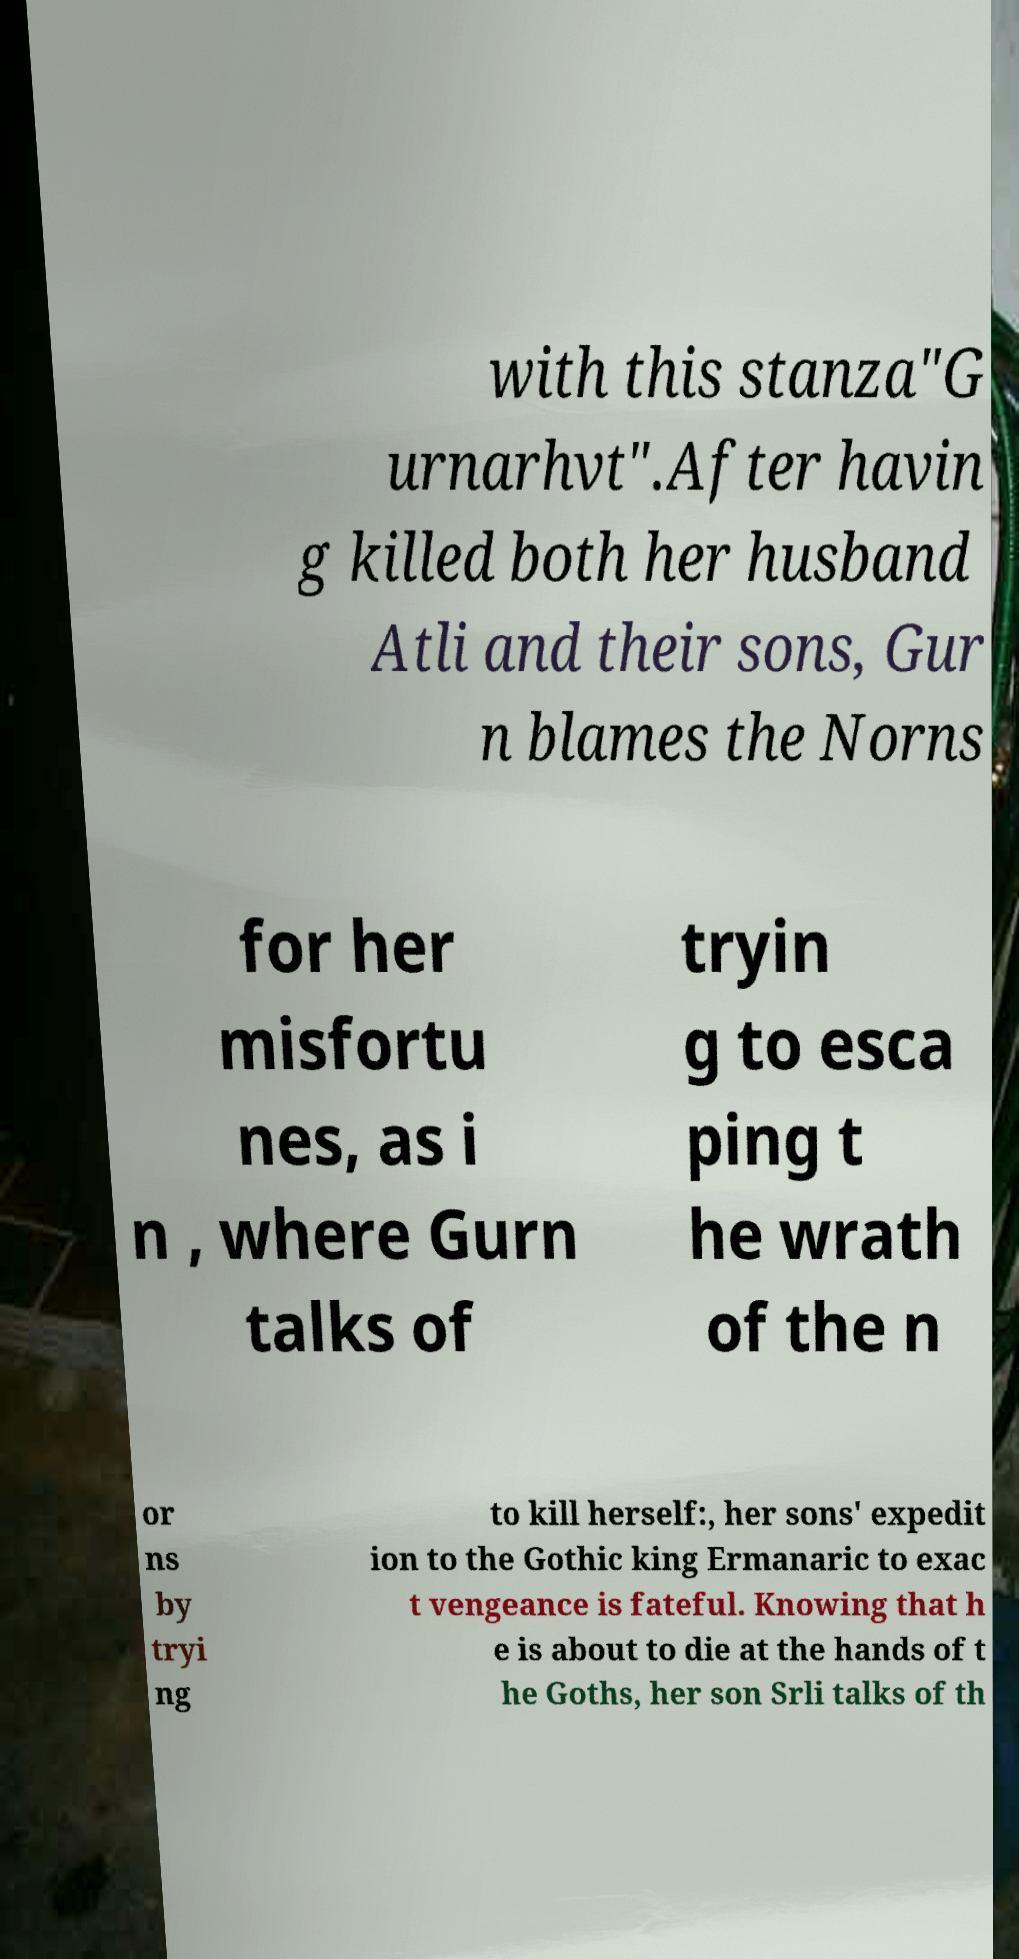I need the written content from this picture converted into text. Can you do that? with this stanza"G urnarhvt".After havin g killed both her husband Atli and their sons, Gur n blames the Norns for her misfortu nes, as i n , where Gurn talks of tryin g to esca ping t he wrath of the n or ns by tryi ng to kill herself:, her sons' expedit ion to the Gothic king Ermanaric to exac t vengeance is fateful. Knowing that h e is about to die at the hands of t he Goths, her son Srli talks of th 